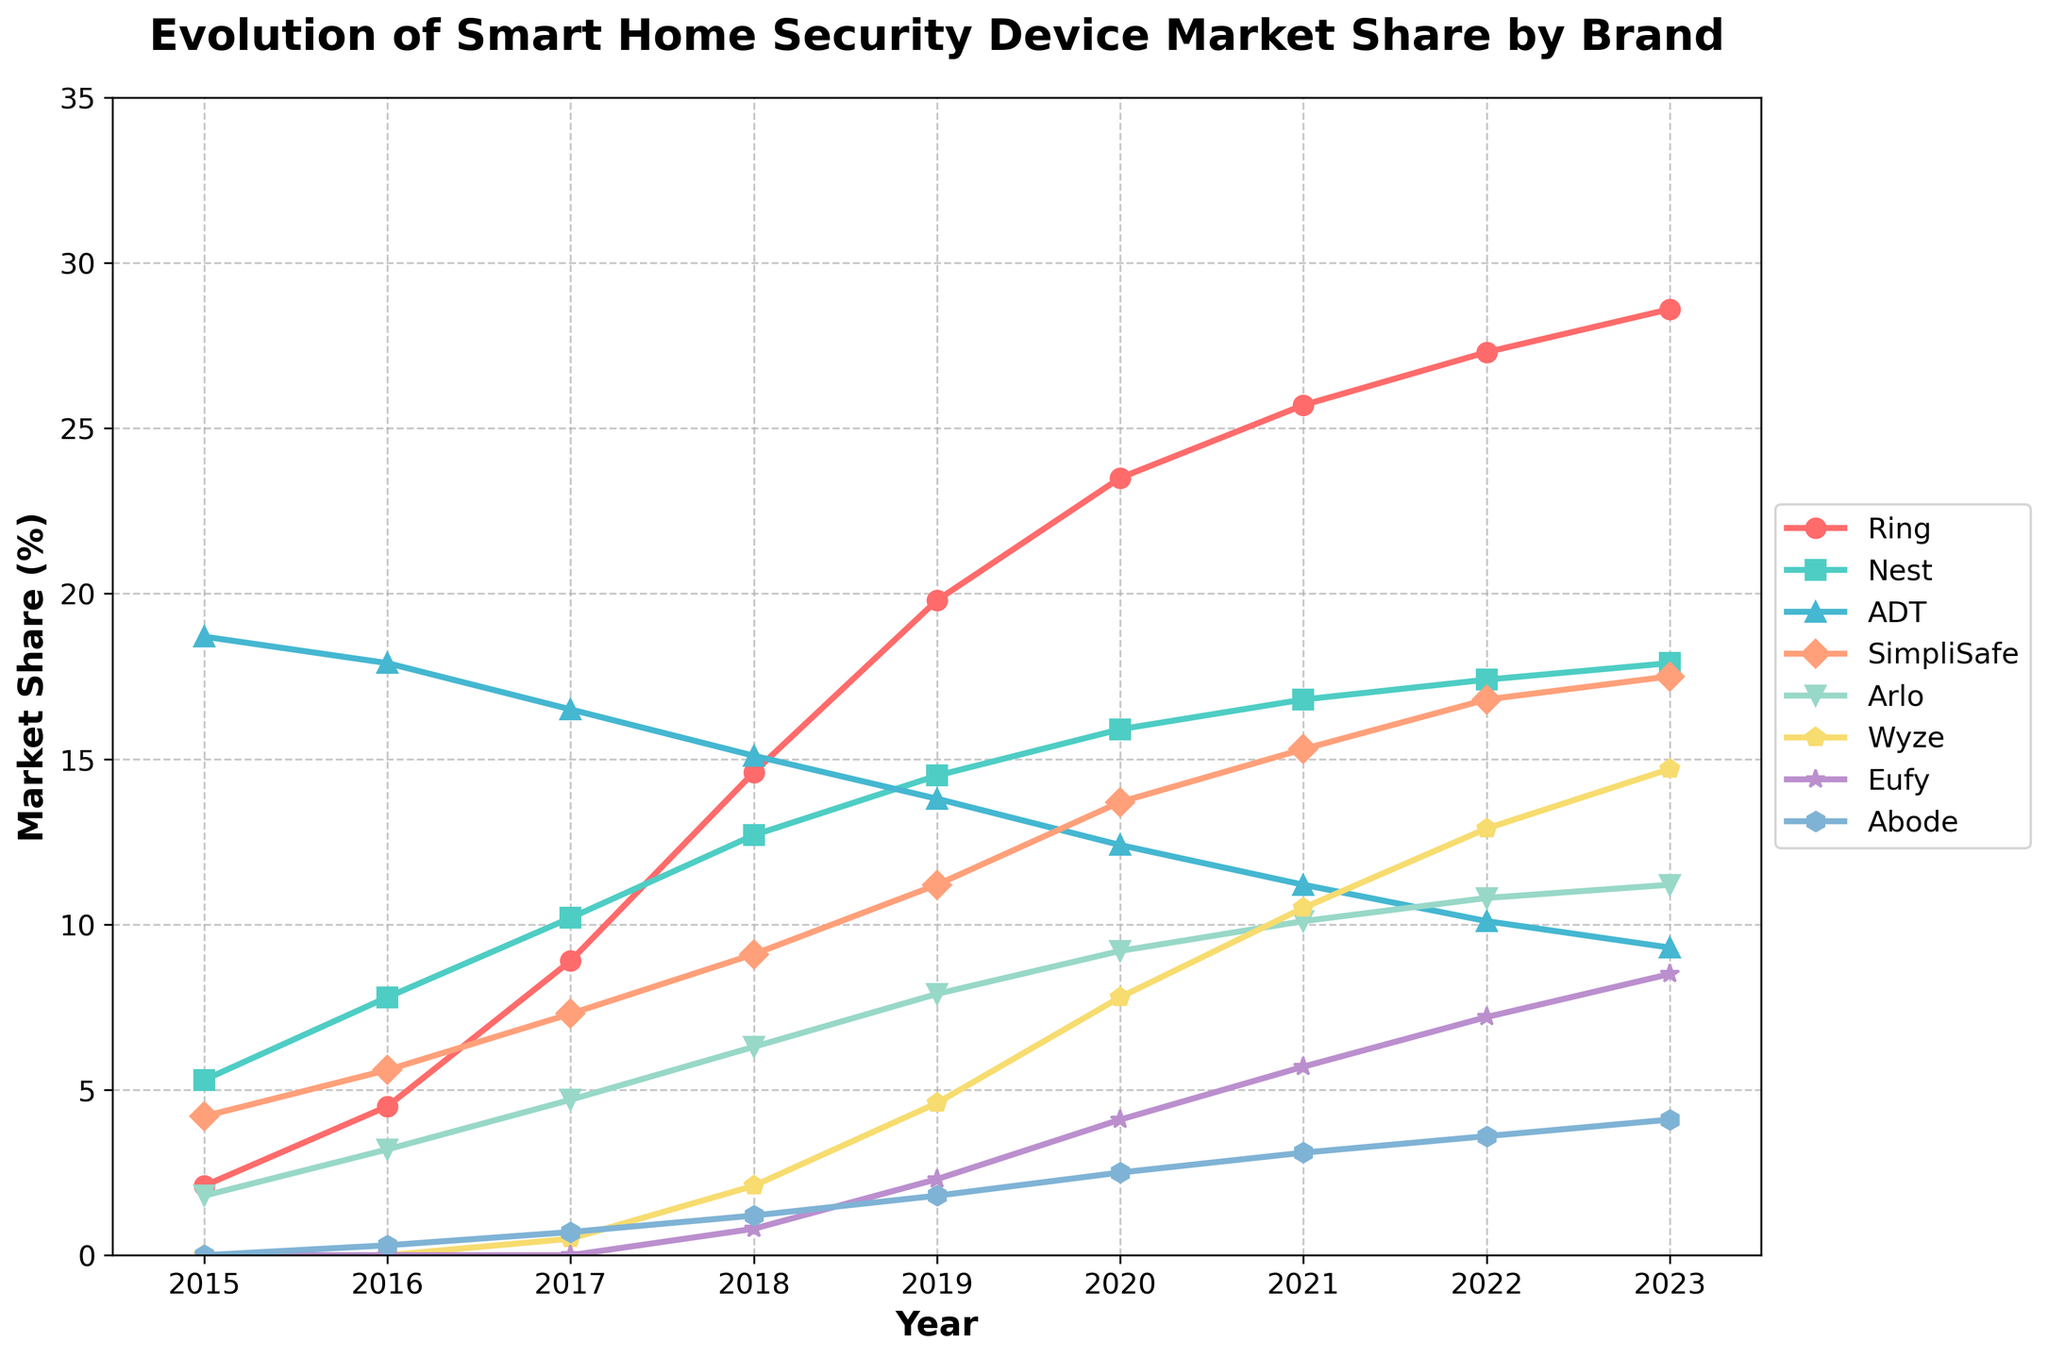Which brand had the highest market share in 2023? The figure shows the market shares of various brands in 2023. The brand with the tallest line at this point is Ring.
Answer: Ring What was the market share difference between Ring and ADT in 2015? The market share of Ring in 2015 was 2.1%, and the market share of ADT was 18.7%. The difference is calculated as 18.7% - 2.1% = 16.6%.
Answer: 16.6% How many brands had increasing market shares every year from 2015 to 2023? By observing the trends of each brand in the figure, we see that Ring continuously increases its market share each year from 2015 to 2023.
Answer: 1 Between 2018 and 2023, which brand experienced the largest increase in market share? The market share of each brand in 2018 and 2023 are noted. The difference for each is calculated:
Ring (28.6 - 14.6) = 14.0,
Nest (17.9 - 12.7) = 5.2,
ADT (9.3 - 15.1) = -5.8,
SimpliSafe (17.5 - 9.1) = 8.4,
Arlo (11.2 - 6.3) = 4.9,
Wyze (14.7 - 2.1) = 12.6,
Eufy (8.5 - 0.8) = 7.7,
Abode (4.1 - 1.2) = 2.9. 
Ring experienced the largest increase.
Answer: Ring What is the average market share of Wyze from 2017 to 2023? The market shares of Wyze from 2017 to 2023 are: 0.5, 2.1, 4.6, 7.8, 10.5, 12.9, 14.7. Summing them up: 0.5 + 2.1 + 4.6 + 7.8 + 10.5 + 12.9 + 14.7 = 53.1 %. Dividing by the number of years (7) yields 53.1 / 7 ≈ 7.6%.
Answer: 7.6% Which brand's market share had the least variation throughout the years? To determine the least variation, observe the fluctuations for each brand. ADT's market share shows the least ups and downs, moving slightly downward but remaining within a smaller range from 18.7% in 2015 to 9.3% in 2023.
Answer: ADT Which brand surpassed Arlo in market share first? Looking at the timeline and noticing when a brand's line passes above Arlo's line, we see that SimpliSafe surpassed Arlo first around 2016.
Answer: SimpliSafe 